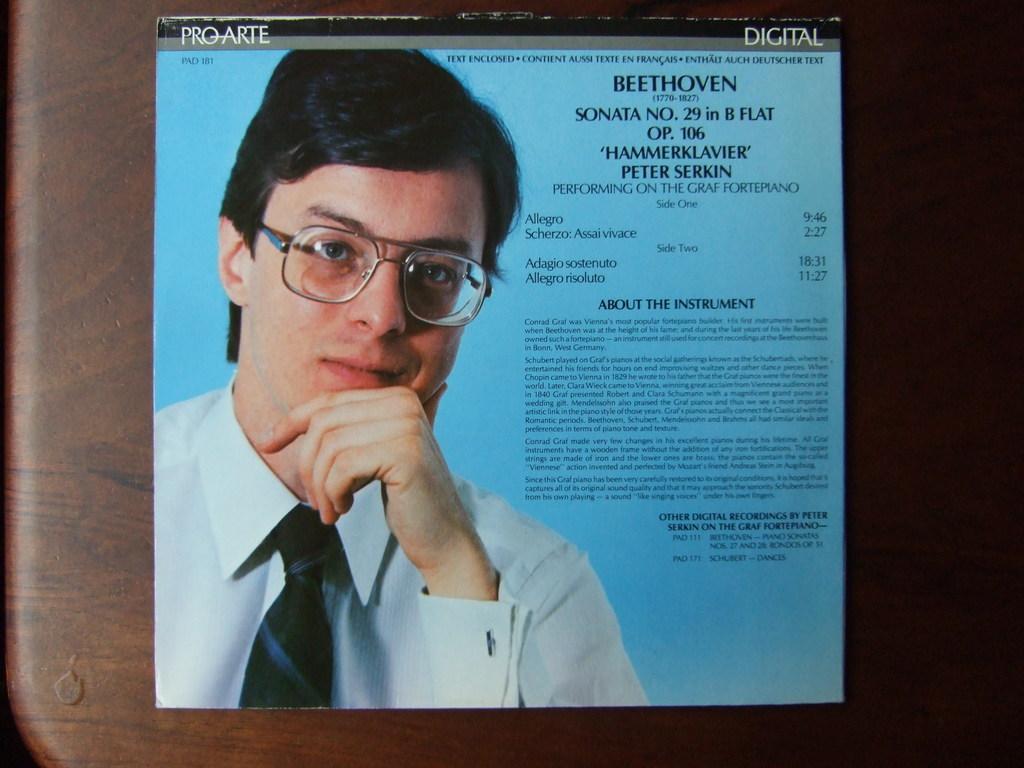Please provide a concise description of this image. In this image I can see a paper on the brown color surface. In the paper I can see a person wearing white shirt, black tie and I can see something written on the paper and the paper is in blue color. 